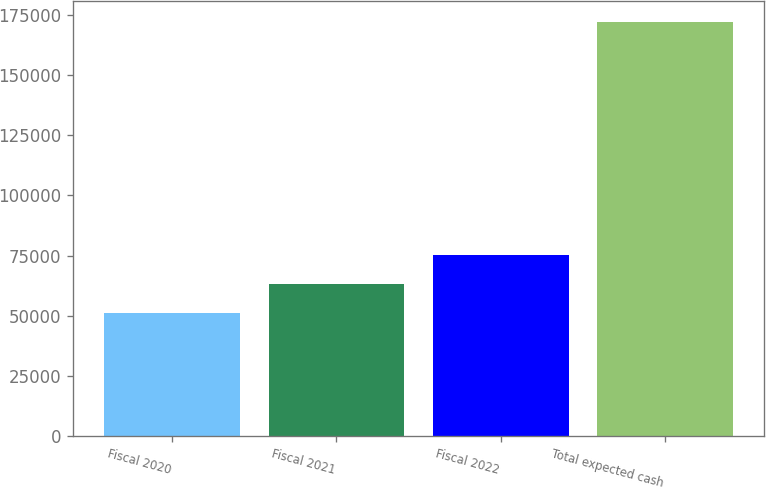Convert chart. <chart><loc_0><loc_0><loc_500><loc_500><bar_chart><fcel>Fiscal 2020<fcel>Fiscal 2021<fcel>Fiscal 2022<fcel>Total expected cash<nl><fcel>50988<fcel>63125.5<fcel>75263<fcel>172363<nl></chart> 